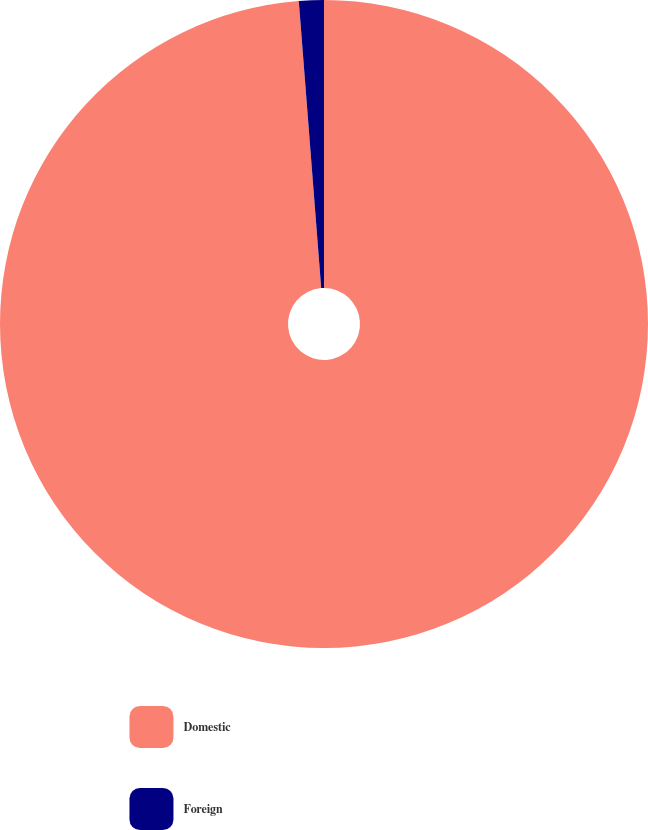Convert chart. <chart><loc_0><loc_0><loc_500><loc_500><pie_chart><fcel>Domestic<fcel>Foreign<nl><fcel>98.76%<fcel>1.24%<nl></chart> 